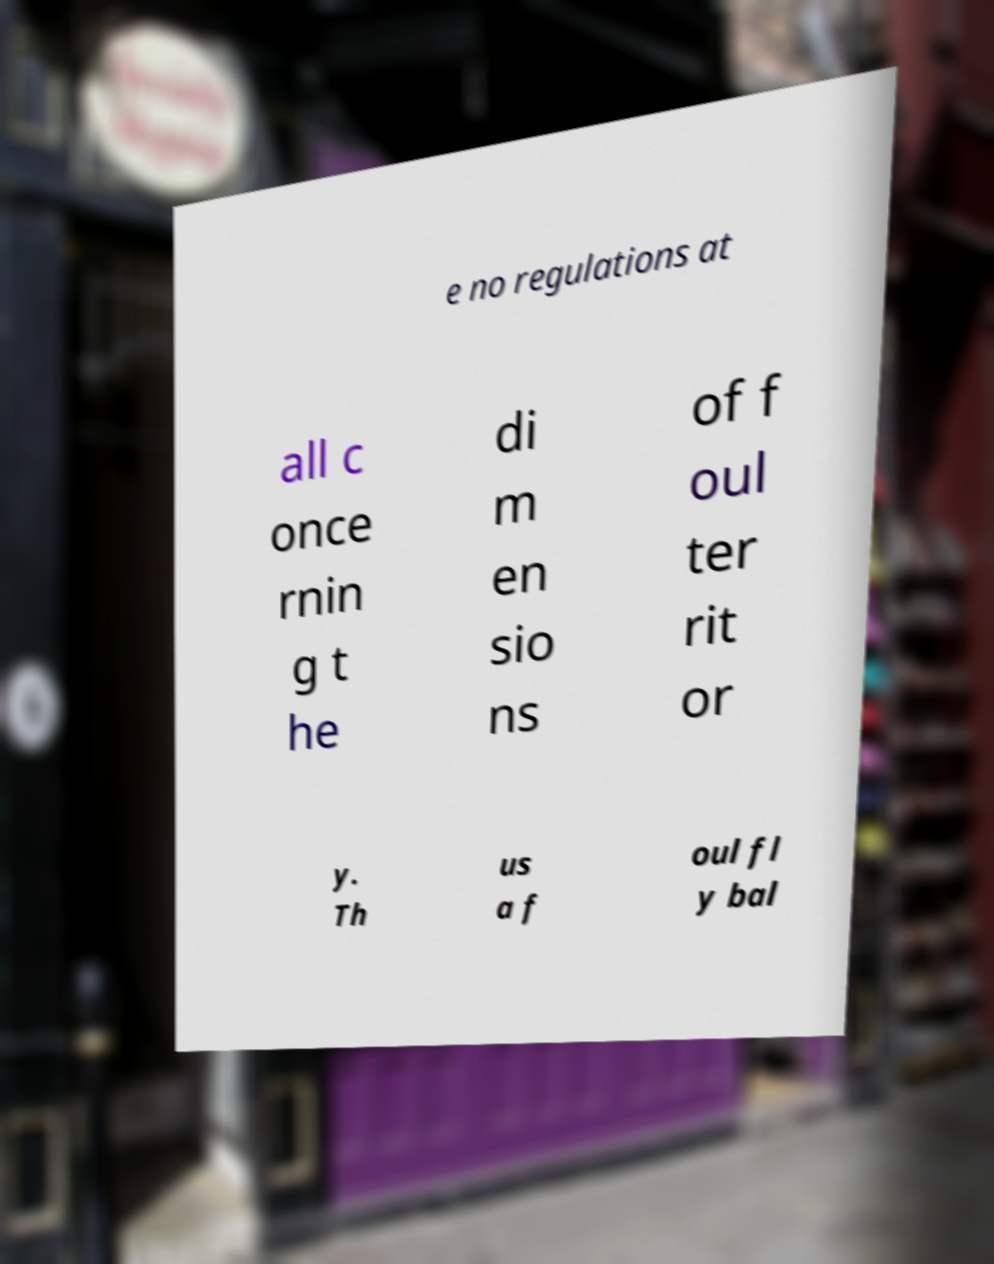Please identify and transcribe the text found in this image. e no regulations at all c once rnin g t he di m en sio ns of f oul ter rit or y. Th us a f oul fl y bal 